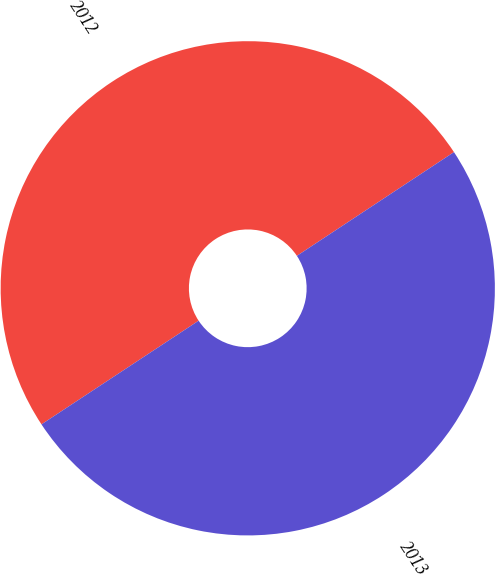<chart> <loc_0><loc_0><loc_500><loc_500><pie_chart><fcel>2012<fcel>2013<nl><fcel>49.99%<fcel>50.01%<nl></chart> 